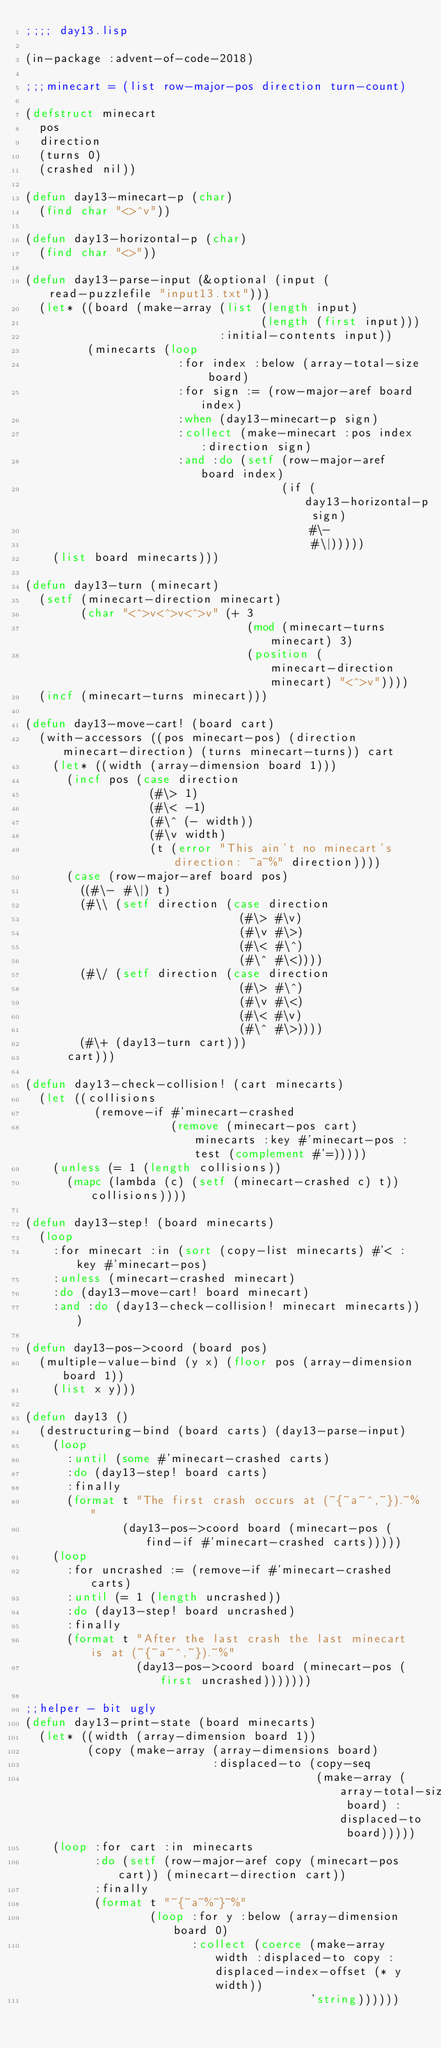Convert code to text. <code><loc_0><loc_0><loc_500><loc_500><_Lisp_>;;;; day13.lisp

(in-package :advent-of-code-2018)

;;;minecart = (list row-major-pos direction turn-count)

(defstruct minecart
  pos
  direction
  (turns 0)
  (crashed nil))

(defun day13-minecart-p (char)
  (find char "<>^v"))

(defun day13-horizontal-p (char)
  (find char "<>"))

(defun day13-parse-input (&optional (input (read-puzzlefile "input13.txt")))
  (let* ((board (make-array (list (length input)
                                  (length (first input)))
                            :initial-contents input))
         (minecarts (loop 
                      :for index :below (array-total-size board)
                      :for sign := (row-major-aref board index)
                      :when (day13-minecart-p sign)
                      :collect (make-minecart :pos index :direction sign)
                      :and :do (setf (row-major-aref board index)
                                     (if (day13-horizontal-p sign)
                                         #\-
                                         #\|)))))
    (list board minecarts)))

(defun day13-turn (minecart)
  (setf (minecart-direction minecart)
        (char "<^>v<^>v<^>v" (+ 3
                                (mod (minecart-turns minecart) 3)
                                (position (minecart-direction minecart) "<^>v"))))
  (incf (minecart-turns minecart)))

(defun day13-move-cart! (board cart)
  (with-accessors ((pos minecart-pos) (direction minecart-direction) (turns minecart-turns)) cart
    (let* ((width (array-dimension board 1)))
      (incf pos (case direction
                  (#\> 1)
                  (#\< -1)
                  (#\^ (- width))
                  (#\v width)
                  (t (error "This ain't no minecart's direction: ~a~%" direction))))
      (case (row-major-aref board pos)
        ((#\- #\|) t)
        (#\\ (setf direction (case direction
                               (#\> #\v)
                               (#\v #\>)
                               (#\< #\^)
                               (#\^ #\<))))
        (#\/ (setf direction (case direction
                               (#\> #\^)
                               (#\v #\<)
                               (#\< #\v)
                               (#\^ #\>))))
        (#\+ (day13-turn cart)))
      cart)))

(defun day13-check-collision! (cart minecarts)
  (let ((collisions
          (remove-if #'minecart-crashed
                     (remove (minecart-pos cart) minecarts :key #'minecart-pos :test (complement #'=)))))
    (unless (= 1 (length collisions))
      (mapc (lambda (c) (setf (minecart-crashed c) t)) collisions))))

(defun day13-step! (board minecarts)
  (loop
    :for minecart :in (sort (copy-list minecarts) #'< :key #'minecart-pos)
    :unless (minecart-crashed minecart)
    :do (day13-move-cart! board minecart)
    :and :do (day13-check-collision! minecart minecarts)))

(defun day13-pos->coord (board pos)
  (multiple-value-bind (y x) (floor pos (array-dimension board 1))
    (list x y)))

(defun day13 ()
  (destructuring-bind (board carts) (day13-parse-input)
    (loop
      :until (some #'minecart-crashed carts)
      :do (day13-step! board carts)
      :finally
      (format t "The first crash occurs at (~{~a~^,~}).~%"
              (day13-pos->coord board (minecart-pos (find-if #'minecart-crashed carts)))))
    (loop
      :for uncrashed := (remove-if #'minecart-crashed carts)
      :until (= 1 (length uncrashed))
      :do (day13-step! board uncrashed)
      :finally
      (format t "After the last crash the last minecart is at (~{~a~^,~}).~%"
                (day13-pos->coord board (minecart-pos (first uncrashed)))))))

;;helper - bit ugly
(defun day13-print-state (board minecarts)
  (let* ((width (array-dimension board 1))
         (copy (make-array (array-dimensions board)
                           :displaced-to (copy-seq
                                          (make-array (array-total-size board) :displaced-to board)))))
    (loop :for cart :in minecarts
          :do (setf (row-major-aref copy (minecart-pos cart)) (minecart-direction cart))
          :finally
          (format t "~{~a~%~}~%"
                  (loop :for y :below (array-dimension board 0)
                        :collect (coerce (make-array width :displaced-to copy :displaced-index-offset (* y width))
                                         'string))))))
</code> 